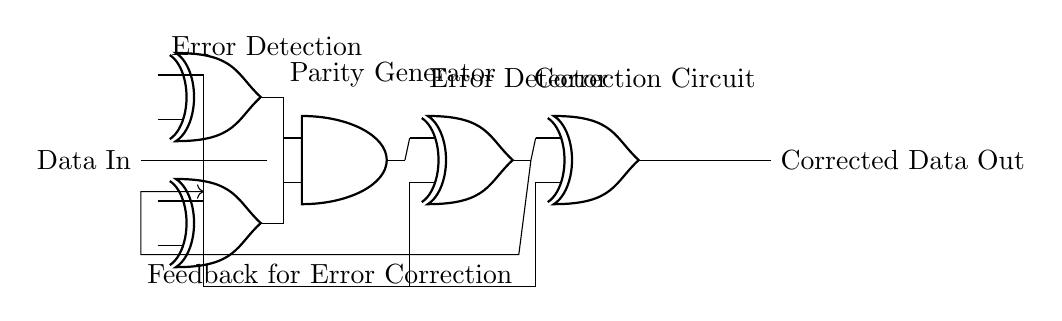What type of logic gates are present in the circuit? The circuit contains XOR and AND gates, which are used for error detection and correction.
Answer: XOR and AND What is the output of the correction circuit? The output from the correction circuit is the corrected data after processing the input through the XOR gates.
Answer: Corrected Data Out How many XOR gates are used for error detection? There are two XOR gates used in the error detection part of the circuit, indicated as xor1 and xor2.
Answer: Two What is the role of the parity generator in the circuit? The parity generator, represented by the AND gate, combines outputs from the XOR gates to generate a parity bit, necessary for error checking.
Answer: Generate parity What feedback mechanism is present in this circuit? The feedback loop in the circuit allows the output from the error detector to be routed back as input, enabling continuous error correction.
Answer: Feedback for correction How is the error detected in this circuit? Error detection is accomplished by comparing the original data input with the output from the parity generator using an XOR gate, which reveals discrepancies.
Answer: Using XOR 